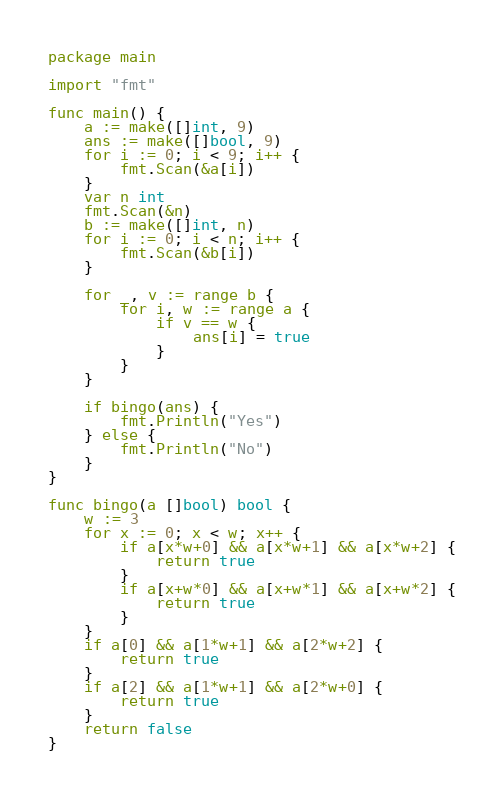<code> <loc_0><loc_0><loc_500><loc_500><_Go_>package main

import "fmt"

func main() {
	a := make([]int, 9)
	ans := make([]bool, 9)
	for i := 0; i < 9; i++ {
		fmt.Scan(&a[i])
	}
	var n int
	fmt.Scan(&n)
	b := make([]int, n)
	for i := 0; i < n; i++ {
		fmt.Scan(&b[i])
	}

	for _, v := range b {
		for i, w := range a {
			if v == w {
				ans[i] = true
			}
		}
	}

	if bingo(ans) {
		fmt.Println("Yes")
	} else {
		fmt.Println("No")
	}
}

func bingo(a []bool) bool {
	w := 3
	for x := 0; x < w; x++ {
		if a[x*w+0] && a[x*w+1] && a[x*w+2] {
			return true
		}
		if a[x+w*0] && a[x+w*1] && a[x+w*2] {
			return true
		}
	}
	if a[0] && a[1*w+1] && a[2*w+2] {
		return true
	}
	if a[2] && a[1*w+1] && a[2*w+0] {
		return true
	}
	return false
}
</code> 